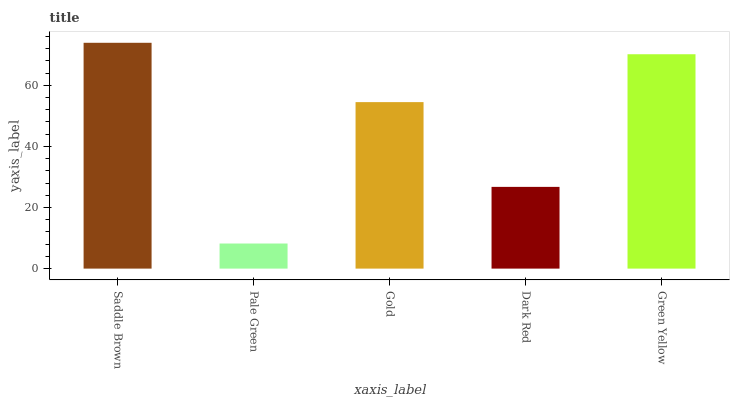Is Pale Green the minimum?
Answer yes or no. Yes. Is Saddle Brown the maximum?
Answer yes or no. Yes. Is Gold the minimum?
Answer yes or no. No. Is Gold the maximum?
Answer yes or no. No. Is Gold greater than Pale Green?
Answer yes or no. Yes. Is Pale Green less than Gold?
Answer yes or no. Yes. Is Pale Green greater than Gold?
Answer yes or no. No. Is Gold less than Pale Green?
Answer yes or no. No. Is Gold the high median?
Answer yes or no. Yes. Is Gold the low median?
Answer yes or no. Yes. Is Pale Green the high median?
Answer yes or no. No. Is Green Yellow the low median?
Answer yes or no. No. 